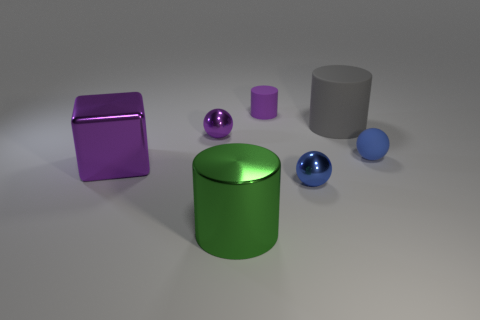Can you describe the lighting in the scene? Certainly. The lighting in the scene appears to be diffuse, as indicated by the soft shadows beneath the objects. It seems as if there's a single, broad light source coming from above, casting gentle shadows and providing a balanced illumination without harsh contrasts. 